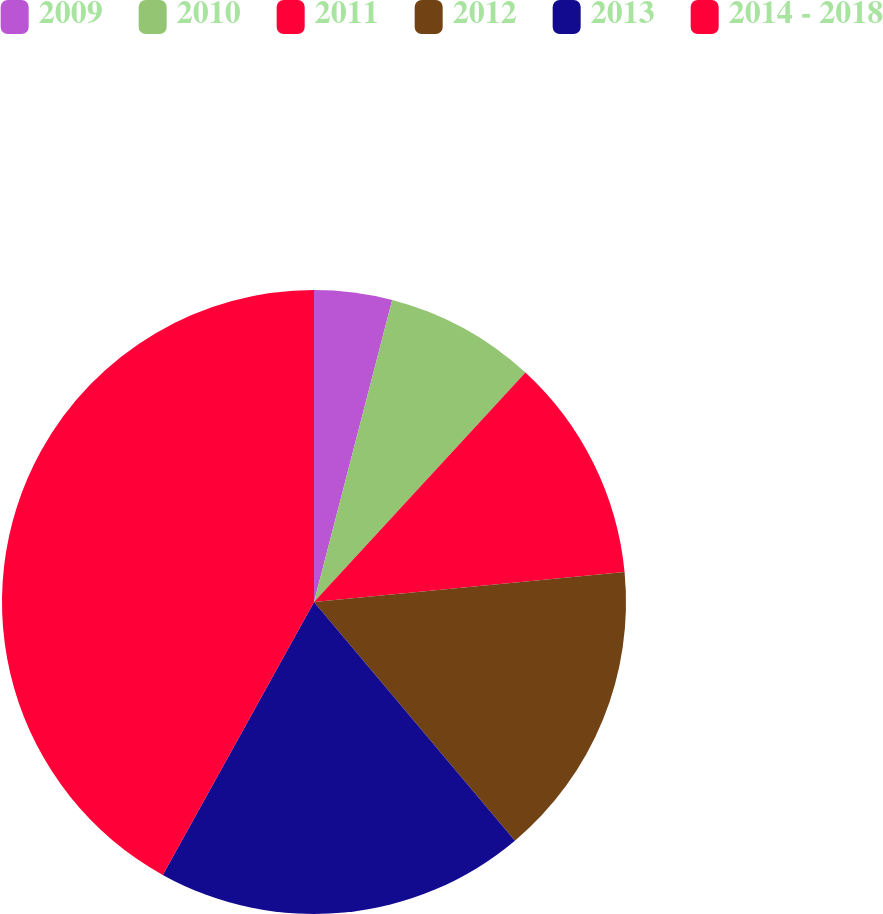Convert chart. <chart><loc_0><loc_0><loc_500><loc_500><pie_chart><fcel>2009<fcel>2010<fcel>2011<fcel>2012<fcel>2013<fcel>2014 - 2018<nl><fcel>4.03%<fcel>7.82%<fcel>11.61%<fcel>15.4%<fcel>19.19%<fcel>41.94%<nl></chart> 